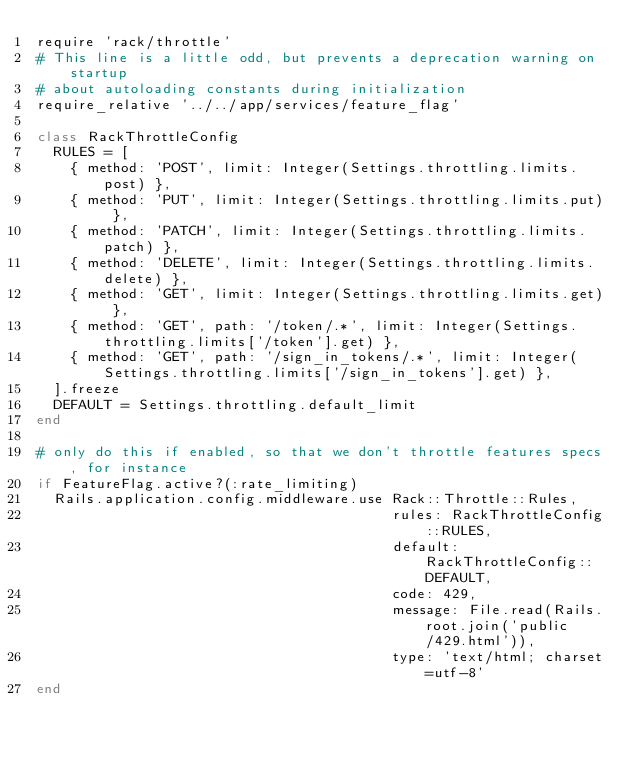<code> <loc_0><loc_0><loc_500><loc_500><_Ruby_>require 'rack/throttle'
# This line is a little odd, but prevents a deprecation warning on startup
# about autoloading constants during initialization
require_relative '../../app/services/feature_flag'

class RackThrottleConfig
  RULES = [
    { method: 'POST', limit: Integer(Settings.throttling.limits.post) },
    { method: 'PUT', limit: Integer(Settings.throttling.limits.put) },
    { method: 'PATCH', limit: Integer(Settings.throttling.limits.patch) },
    { method: 'DELETE', limit: Integer(Settings.throttling.limits.delete) },
    { method: 'GET', limit: Integer(Settings.throttling.limits.get) },
    { method: 'GET', path: '/token/.*', limit: Integer(Settings.throttling.limits['/token'].get) },
    { method: 'GET', path: '/sign_in_tokens/.*', limit: Integer(Settings.throttling.limits['/sign_in_tokens'].get) },
  ].freeze
  DEFAULT = Settings.throttling.default_limit
end

# only do this if enabled, so that we don't throttle features specs, for instance
if FeatureFlag.active?(:rate_limiting)
  Rails.application.config.middleware.use Rack::Throttle::Rules,
                                          rules: RackThrottleConfig::RULES,
                                          default: RackThrottleConfig::DEFAULT,
                                          code: 429,
                                          message: File.read(Rails.root.join('public/429.html')),
                                          type: 'text/html; charset=utf-8'
end
</code> 